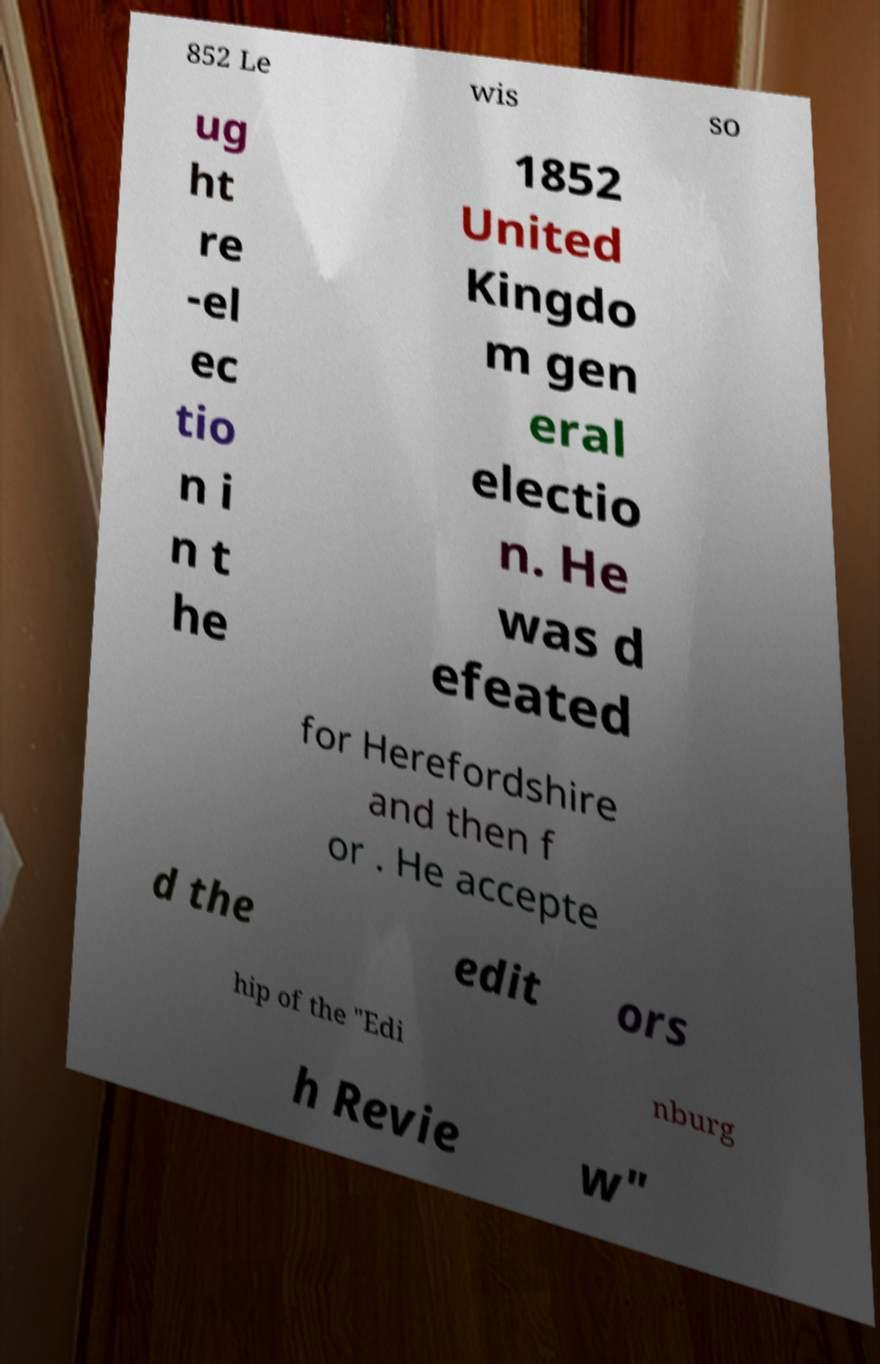Can you accurately transcribe the text from the provided image for me? 852 Le wis so ug ht re -el ec tio n i n t he 1852 United Kingdo m gen eral electio n. He was d efeated for Herefordshire and then f or . He accepte d the edit ors hip of the "Edi nburg h Revie w" 